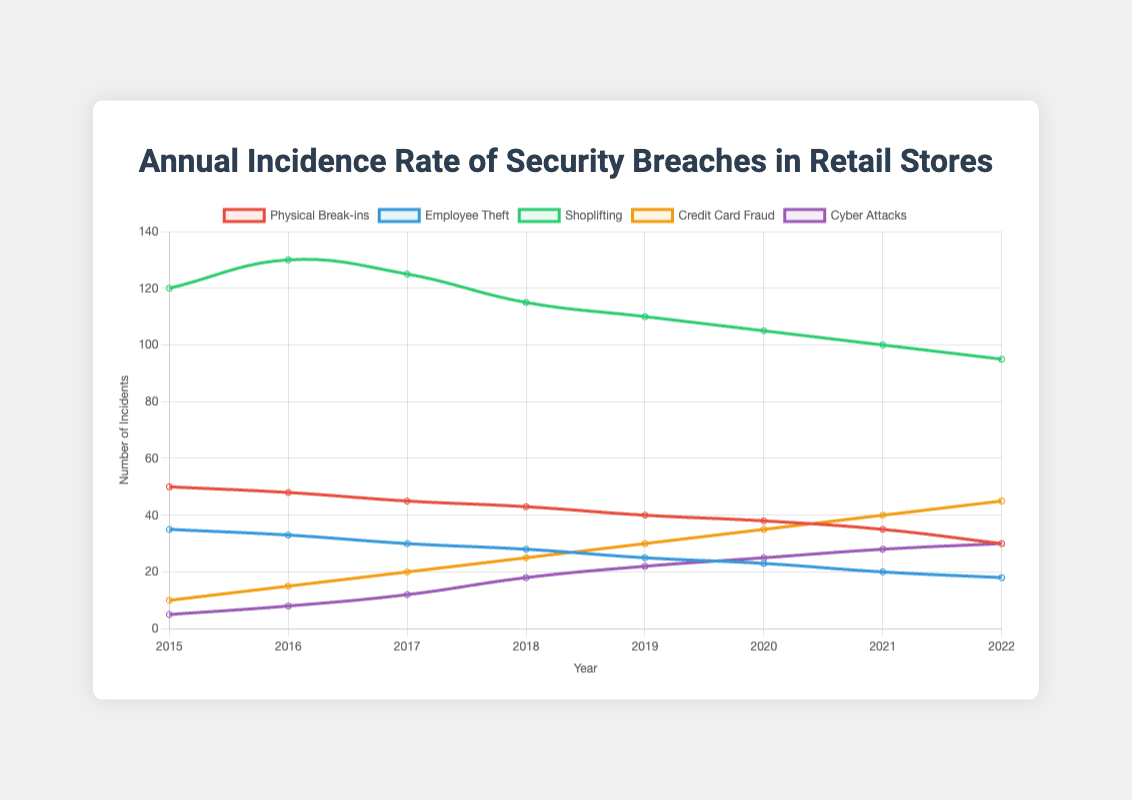What year had the highest number of shoplifting incidents? The highest number of shoplifting incidents is visible at the peak of the green line, which reaches 130 in 2016.
Answer: 2016 By how much did the number of credit card fraud incidents increase from 2015 to 2022? The number of credit card fraud incidents in 2015 was 10, increasing to 45 in 2022. The difference is 45 - 10 = 35.
Answer: 35 Which type of security breach had the least incidents in 2020? The purple line representing cyber attacks is the lowest in 2020, at 25 incidents.
Answer: Cyber Attacks How many total incidents of employee theft occurred between 2017 and 2020 inclusive? Sum the values for employee theft from 2017 to 2020: 30 + 28 + 25 + 23 = 106.
Answer: 106 What is the trend of physical break-ins over the years? The trend of physical break-ins shows a steady decrease each year from 2015 to 2022.
Answer: Decreasing Which year saw the greatest increase in cyber attacks compared to the previous year? Compare yearly increases: 2015 to 2016 (3), 2016 to 2017 (4), 2017 to 2018 (6), 2018 to 2019 (4), 2019 to 2020 (3), 2020 to 2021 (3), and 2021 to 2022 (2). The greatest increase is 6 from 2017 to 2018.
Answer: 2017 to 2018 By what percentage did employee theft decrease from 2015 to 2022? In 2015, employee theft incidents were 35, decreasing to 18 in 2022. The decrease is (35 - 18) = 17. The percentage decrease is (17 / 35) * 100 = 48.57%.
Answer: 48.57% For which type of breach did the number of incidents start and end the same way between 2015 and 2022? The comparison of beginning and end points: physical break-ins (50 to 30), employee theft (35 to 18), shoplifting (120 to 95), credit card fraud (10 to 45), and cyber attacks (5 to 30). None of them start and end the same.
Answer: None 